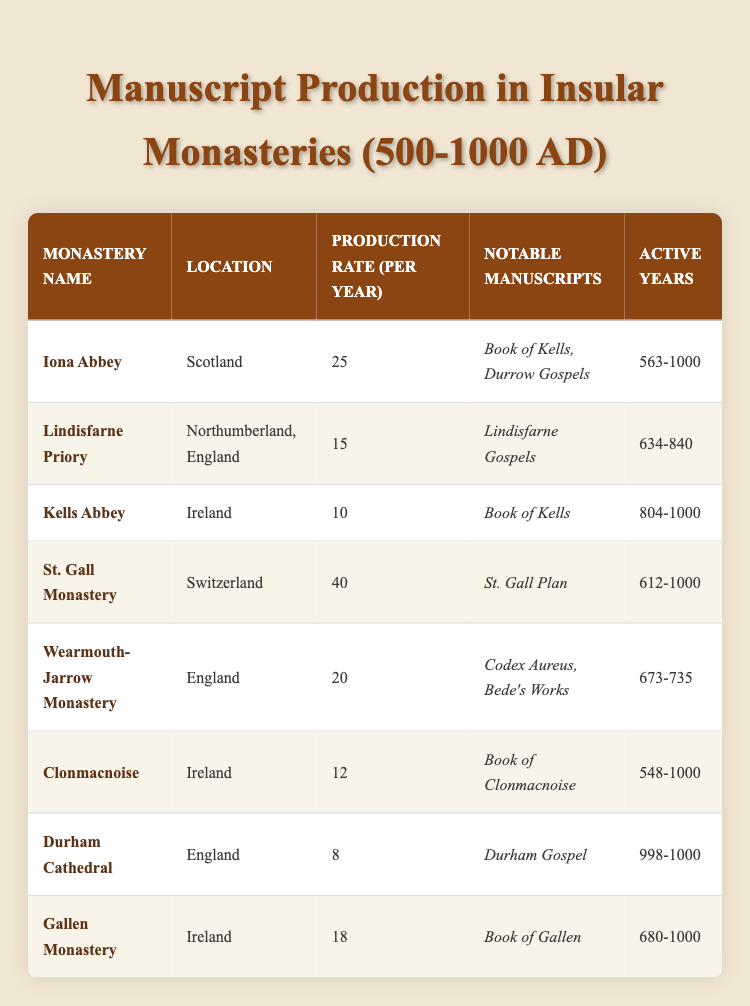What is the highest production rate per year among the monasteries listed? By examining the "Production Rate (per year)" column, St. Gall Monastery has the highest value listed at 40 manuscripts per year.
Answer: 40 Which monastery produced the "Book of Kells"? The "Book of Kells" is noted under Iona Abbey, which has a production rate of 25 manuscripts per year and was active from 563 to 1000.
Answer: Iona Abbey How many manuscripts did Clonmacnoise produce during its most active years? Clonmacnoise was active from 548 to 1000, which is 452 years. With a production rate of 12 manuscripts per year, the total production is 12 multiplied by 452, equaling 5424 manuscripts.
Answer: 5424 Was the Lindisfarne Priory active before or after the year 800? Referring to the "Active Years" for Lindisfarne Priory, it was active from 634 to 840, indicating it was active both before and after the year 800.
Answer: Yes What is the total production rate for the monasteries in Ireland listed in the table? The monasteries located in Ireland are Kells Abbey (10), Clonmacnoise (12), and Gallen Monastery (18). Summing these rates gives 10 + 12 + 18 = 40 manuscripts per year in total.
Answer: 40 How many notable manuscripts are associated with the Wearmouth-Jarrow Monastery? There are two notable manuscripts listed for Wearmouth-Jarrow Monastery: the "Codex Aureus" and "Bede's Works."
Answer: 2 Which monastery had the lowest production rate per year? By checking the "Production Rate (per year)" column, Durham Cathedral has the lowest production at 8 manuscripts per year, compared to the others.
Answer: 8 What is the average production rate across all monasteries listed? To find the average, first add all production rates: 25 + 15 + 10 + 40 + 20 + 12 + 8 + 18 = 148. There are 8 monasteries, so the average is 148 divided by 8, which equals 18.5 manuscripts per year.
Answer: 18.5 Which monastery has been active the longest based on the data provided? Iona Abbey has been active for the longest period, from 563 to 1000, totaling 437 years. Other monasteries have shorter active periods compared to this.
Answer: Iona Abbey 